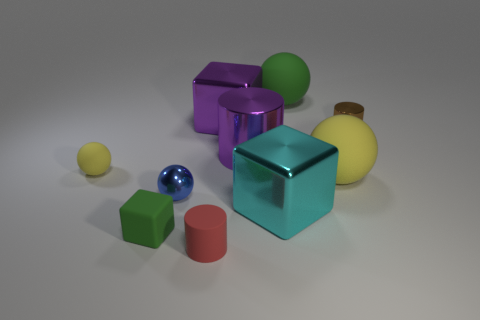There is a yellow matte ball right of the tiny matte cylinder; are there any blue spheres to the right of it?
Ensure brevity in your answer.  No. Is the number of cyan metal objects less than the number of large green matte cylinders?
Keep it short and to the point. No. There is a large sphere that is on the right side of the green matte thing right of the tiny cube; what is it made of?
Keep it short and to the point. Rubber. Do the brown thing and the blue metal sphere have the same size?
Give a very brief answer. Yes. How many objects are either cylinders or tiny brown metal objects?
Your answer should be very brief. 3. What is the size of the rubber object that is both on the right side of the small yellow rubber object and left of the red matte thing?
Make the answer very short. Small. Is the number of big green rubber things that are right of the large yellow thing less than the number of big purple things?
Your answer should be very brief. Yes. What shape is the brown object that is made of the same material as the large cyan block?
Provide a succinct answer. Cylinder. There is a yellow matte thing that is left of the tiny red object; is its shape the same as the green matte thing that is in front of the tiny yellow object?
Your answer should be compact. No. Is the number of shiny cubes that are behind the green matte ball less than the number of large green balls that are in front of the big yellow matte object?
Offer a terse response. No. 